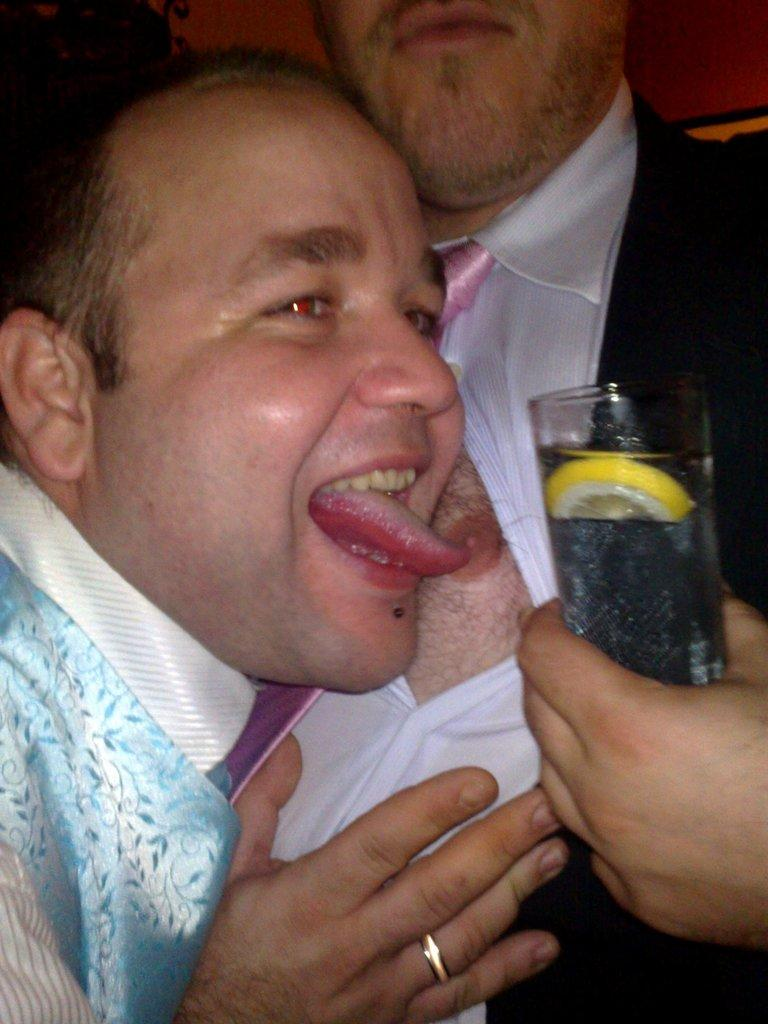How many people are present in the image? There are two people standing in the image. What is one of the people holding? One person is holding a glass of drink. Where is the tray located in the image? There is no tray present in the image. How many men are visible in the image? The number of men cannot be determined from the provided facts, as the gender of the people is not mentioned. 